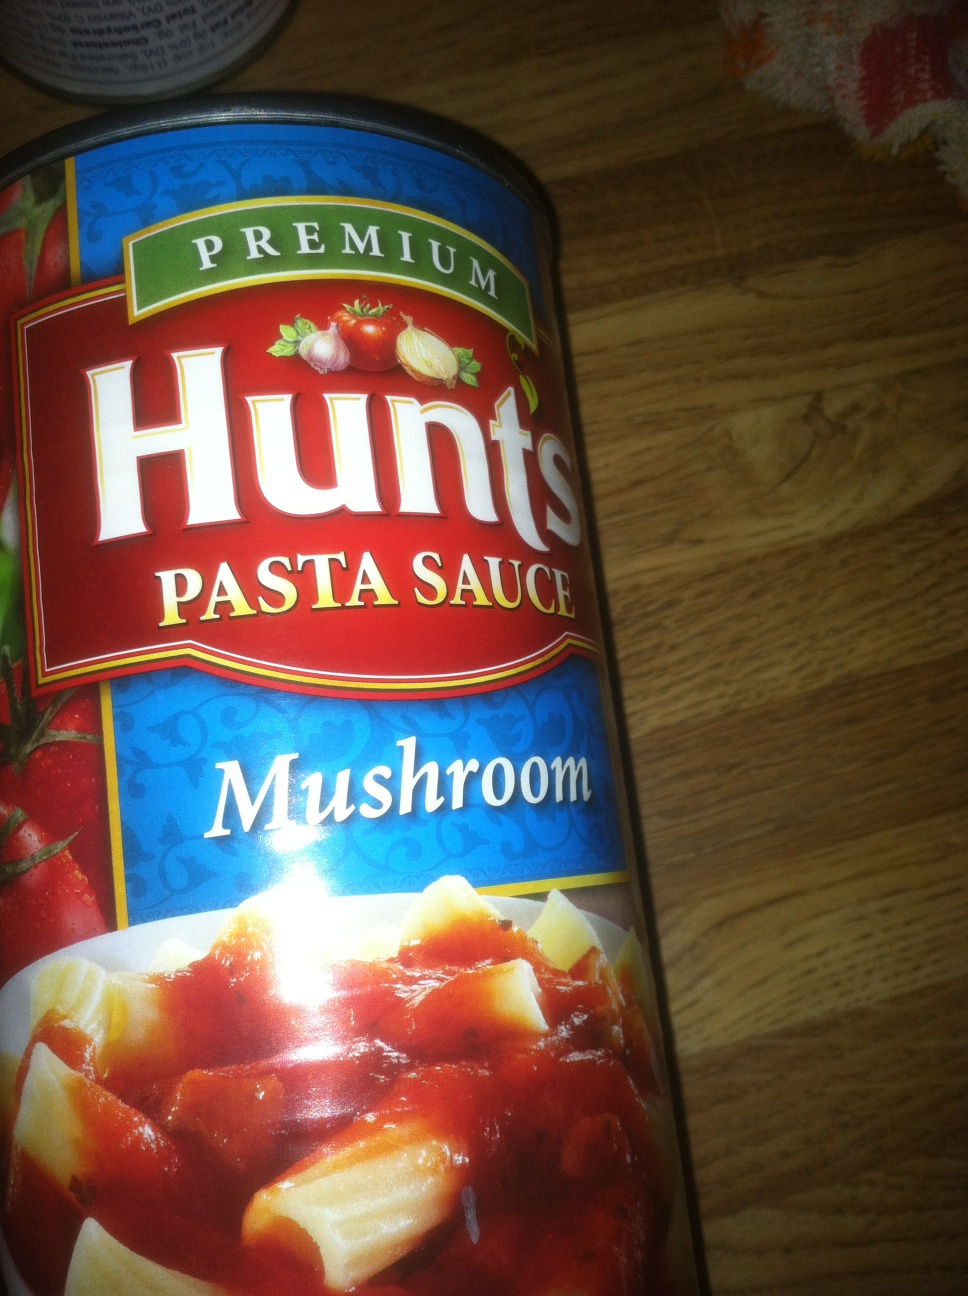What are some key ingredients in this sauce, based on the label? The label highlights tomatoes and mushrooms as key ingredients. It likely also contains herbs and spices to enrich the flavor, perfect for giving your dishes a robust and authentic Italian taste. 